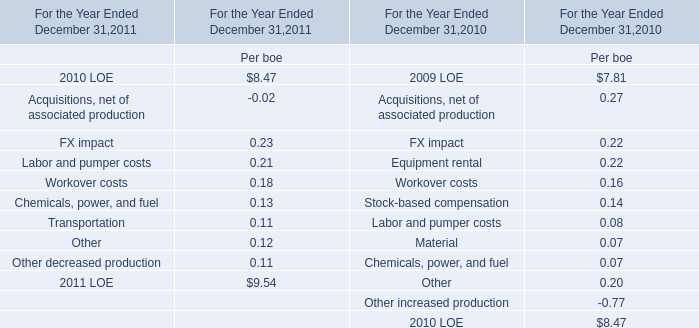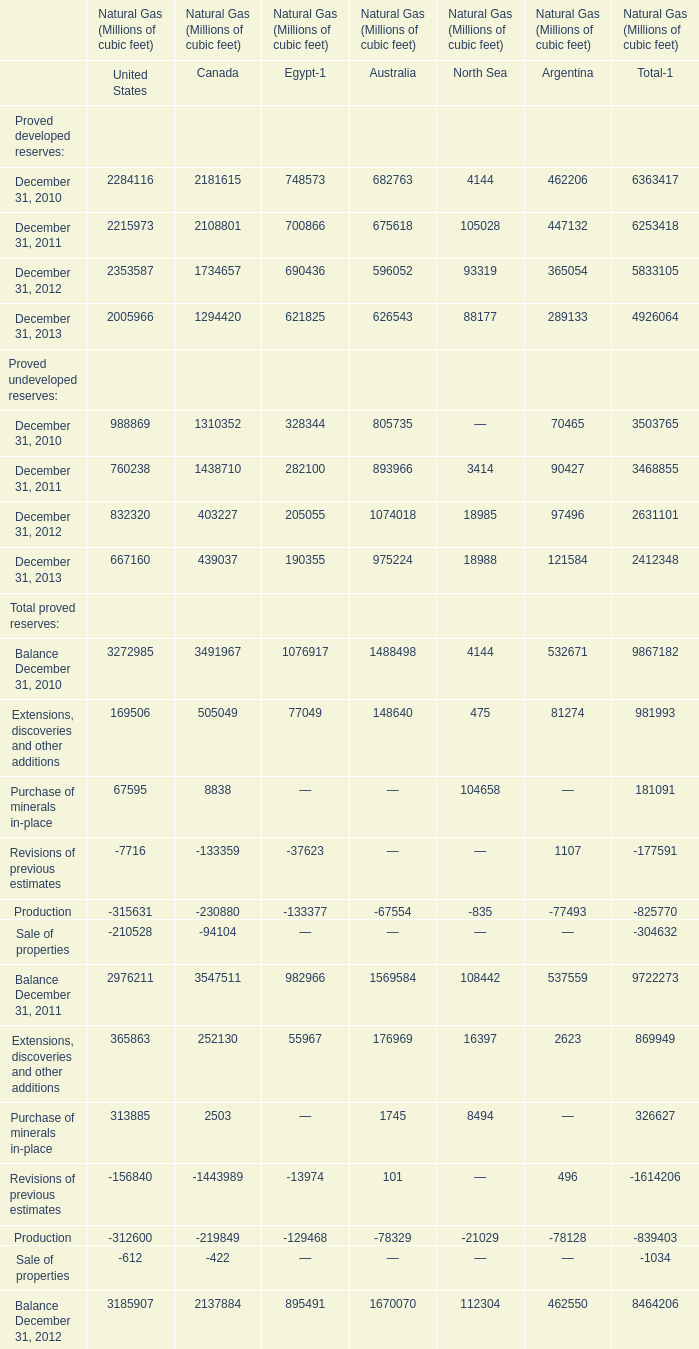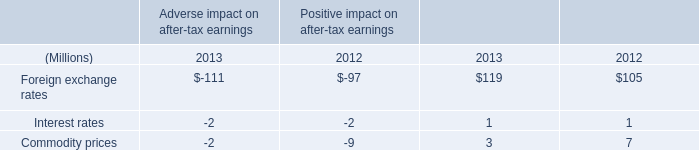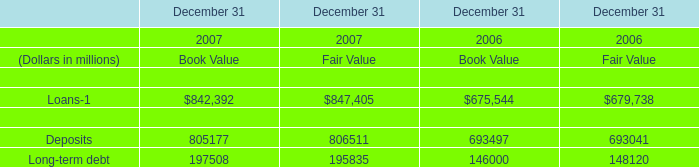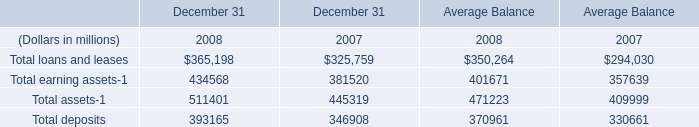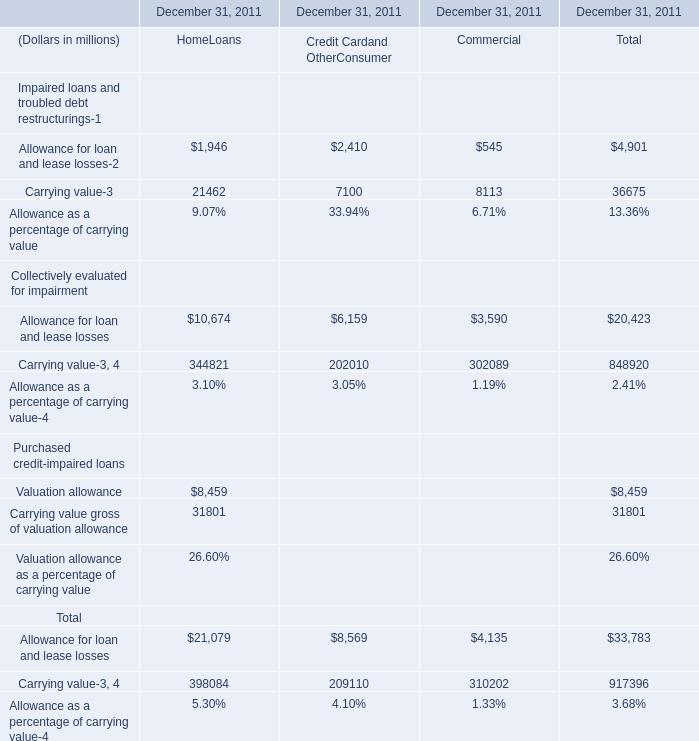Does Proved developed reserves of United States keeps increasing each year between 2012 and 2013? 
Answer: no. 